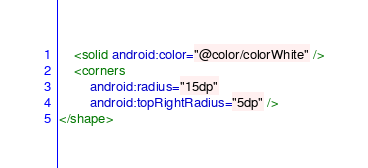<code> <loc_0><loc_0><loc_500><loc_500><_XML_>    <solid android:color="@color/colorWhite" />
    <corners
        android:radius="15dp"
        android:topRightRadius="5dp" />
</shape></code> 